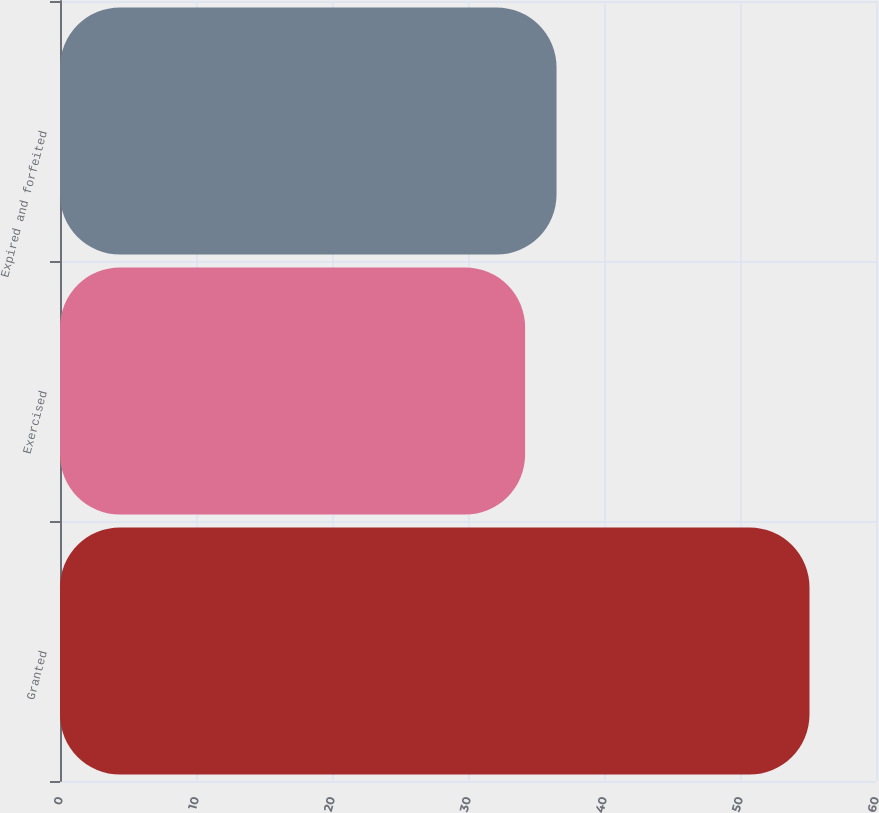<chart> <loc_0><loc_0><loc_500><loc_500><bar_chart><fcel>Granted<fcel>Exercised<fcel>Expired and forfeited<nl><fcel>55.11<fcel>34.2<fcel>36.51<nl></chart> 